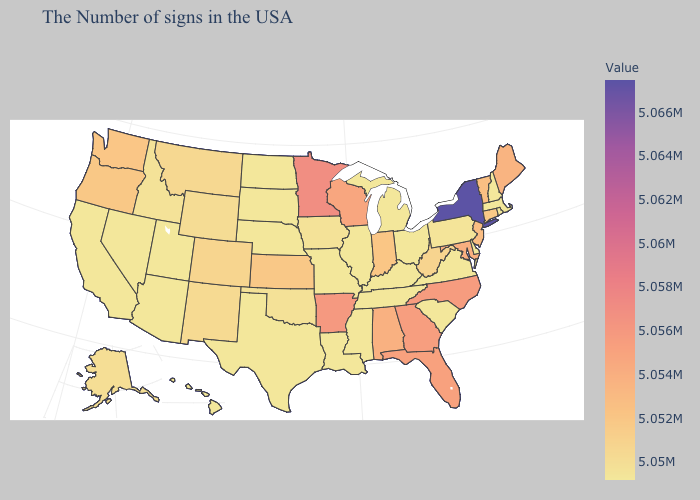Does the map have missing data?
Give a very brief answer. No. Among the states that border New Mexico , which have the lowest value?
Concise answer only. Texas, Utah, Arizona. Among the states that border Minnesota , which have the highest value?
Quick response, please. Wisconsin. Does the map have missing data?
Be succinct. No. Does New York have the highest value in the USA?
Be succinct. Yes. Which states have the lowest value in the USA?
Concise answer only. Massachusetts, Rhode Island, New Hampshire, Delaware, Virginia, South Carolina, Ohio, Michigan, Kentucky, Tennessee, Illinois, Mississippi, Louisiana, Missouri, Nebraska, Texas, South Dakota, North Dakota, Utah, Arizona, Nevada, California, Hawaii. 